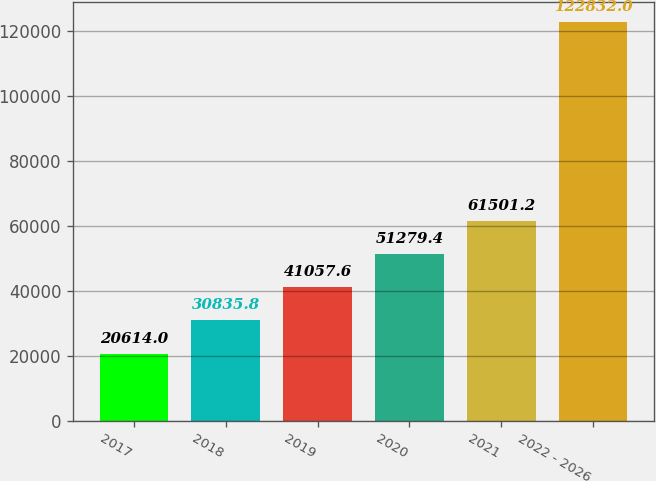Convert chart to OTSL. <chart><loc_0><loc_0><loc_500><loc_500><bar_chart><fcel>2017<fcel>2018<fcel>2019<fcel>2020<fcel>2021<fcel>2022 - 2026<nl><fcel>20614<fcel>30835.8<fcel>41057.6<fcel>51279.4<fcel>61501.2<fcel>122832<nl></chart> 